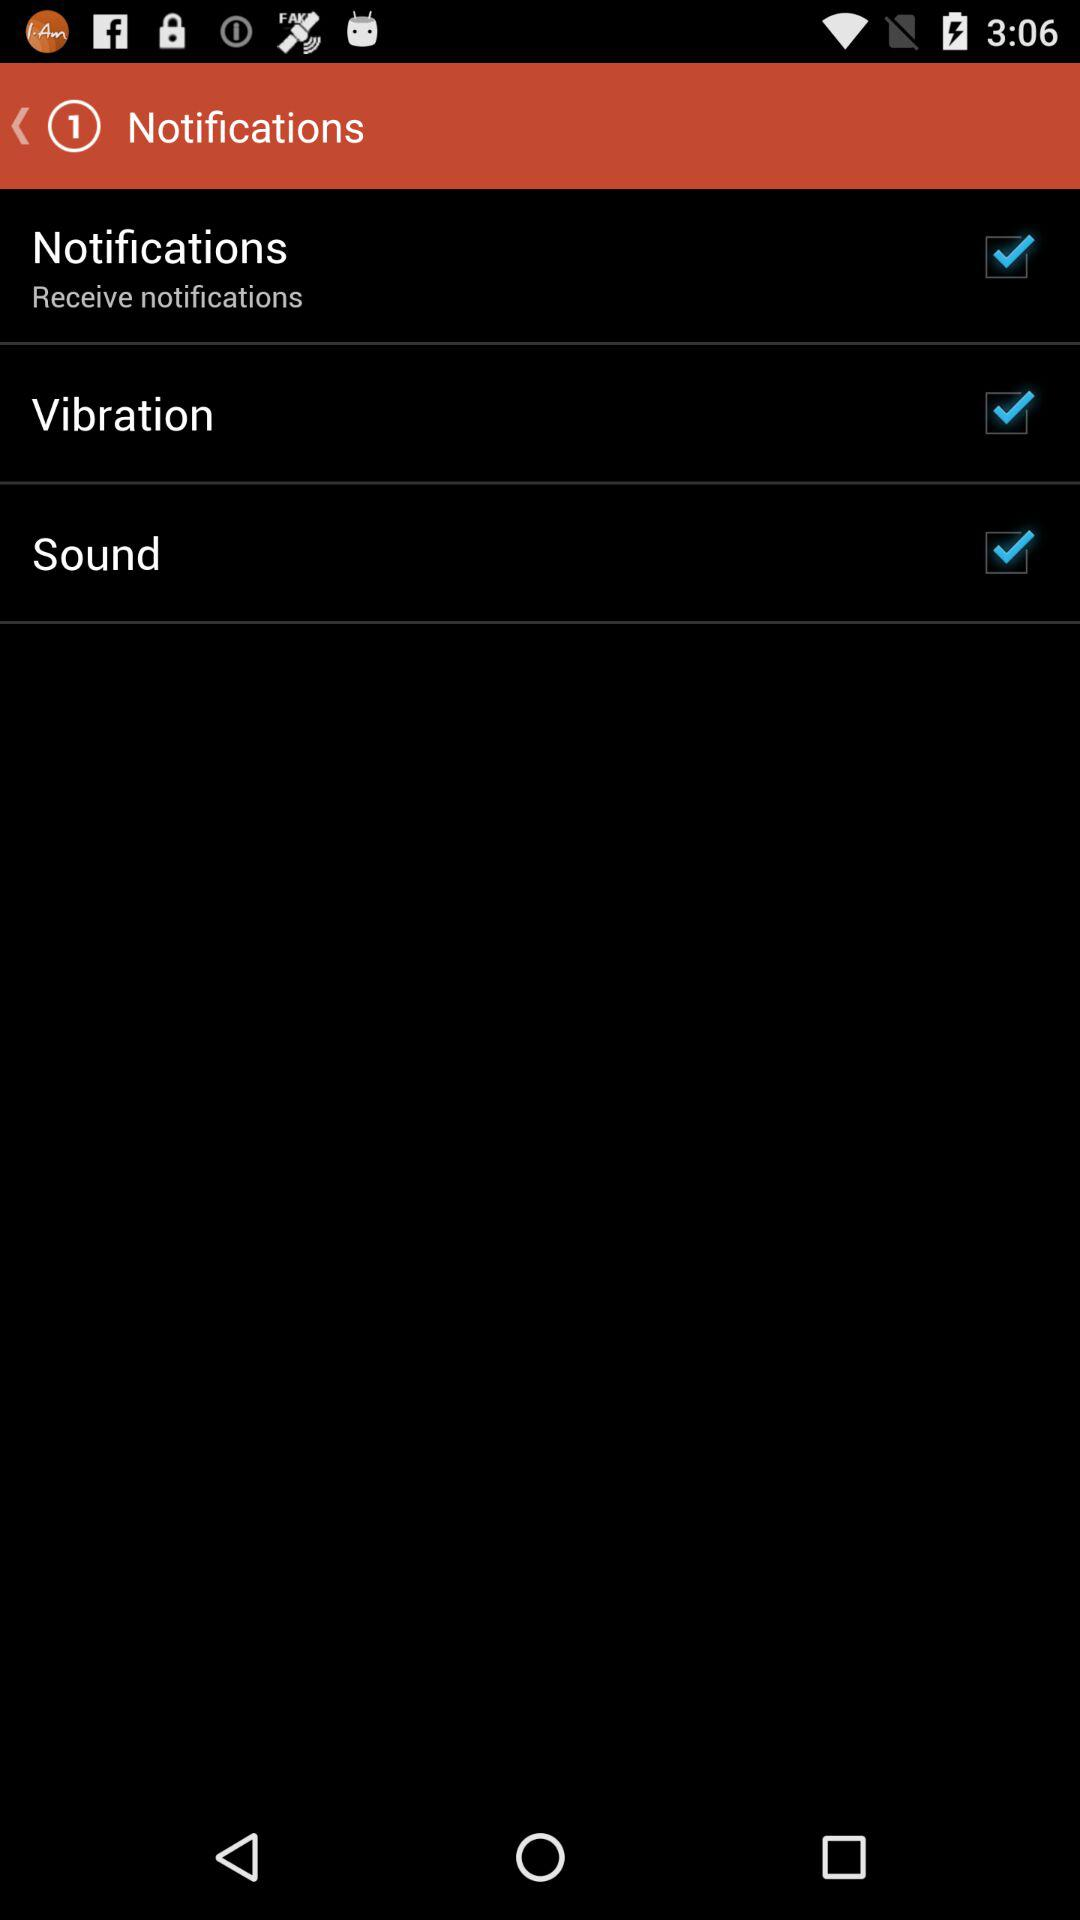What is the setting for vibration? The setting for vibration is "on". 